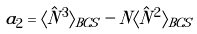<formula> <loc_0><loc_0><loc_500><loc_500>a _ { 2 } = \langle \hat { N } ^ { 3 } \rangle _ { B C S } - N \langle \hat { N } ^ { 2 } \rangle _ { B C S }</formula> 